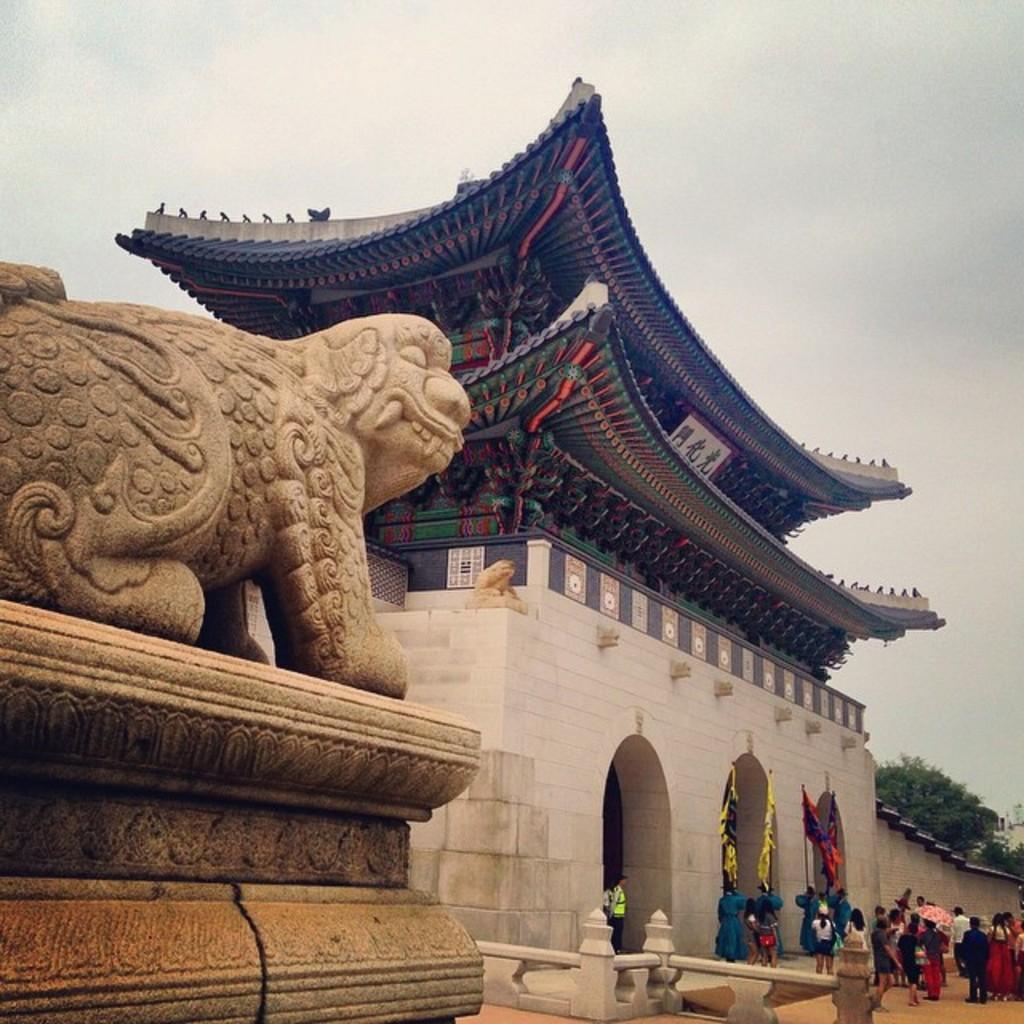Can you describe this image briefly? In this image, we can see a building. There are a few people. We can see some objects attached to the wall of the building. We can also see some flags. We can see the ground and the fence. We can also see a statue on an object. We can also see some trees and the sky. 